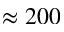<formula> <loc_0><loc_0><loc_500><loc_500>\approx 2 0 0</formula> 